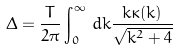Convert formula to latex. <formula><loc_0><loc_0><loc_500><loc_500>\Delta = \frac { T } { 2 \pi } \int _ { 0 } ^ { \infty } \, d k \frac { k \kappa ( k ) } { \sqrt { k ^ { 2 } + 4 } }</formula> 